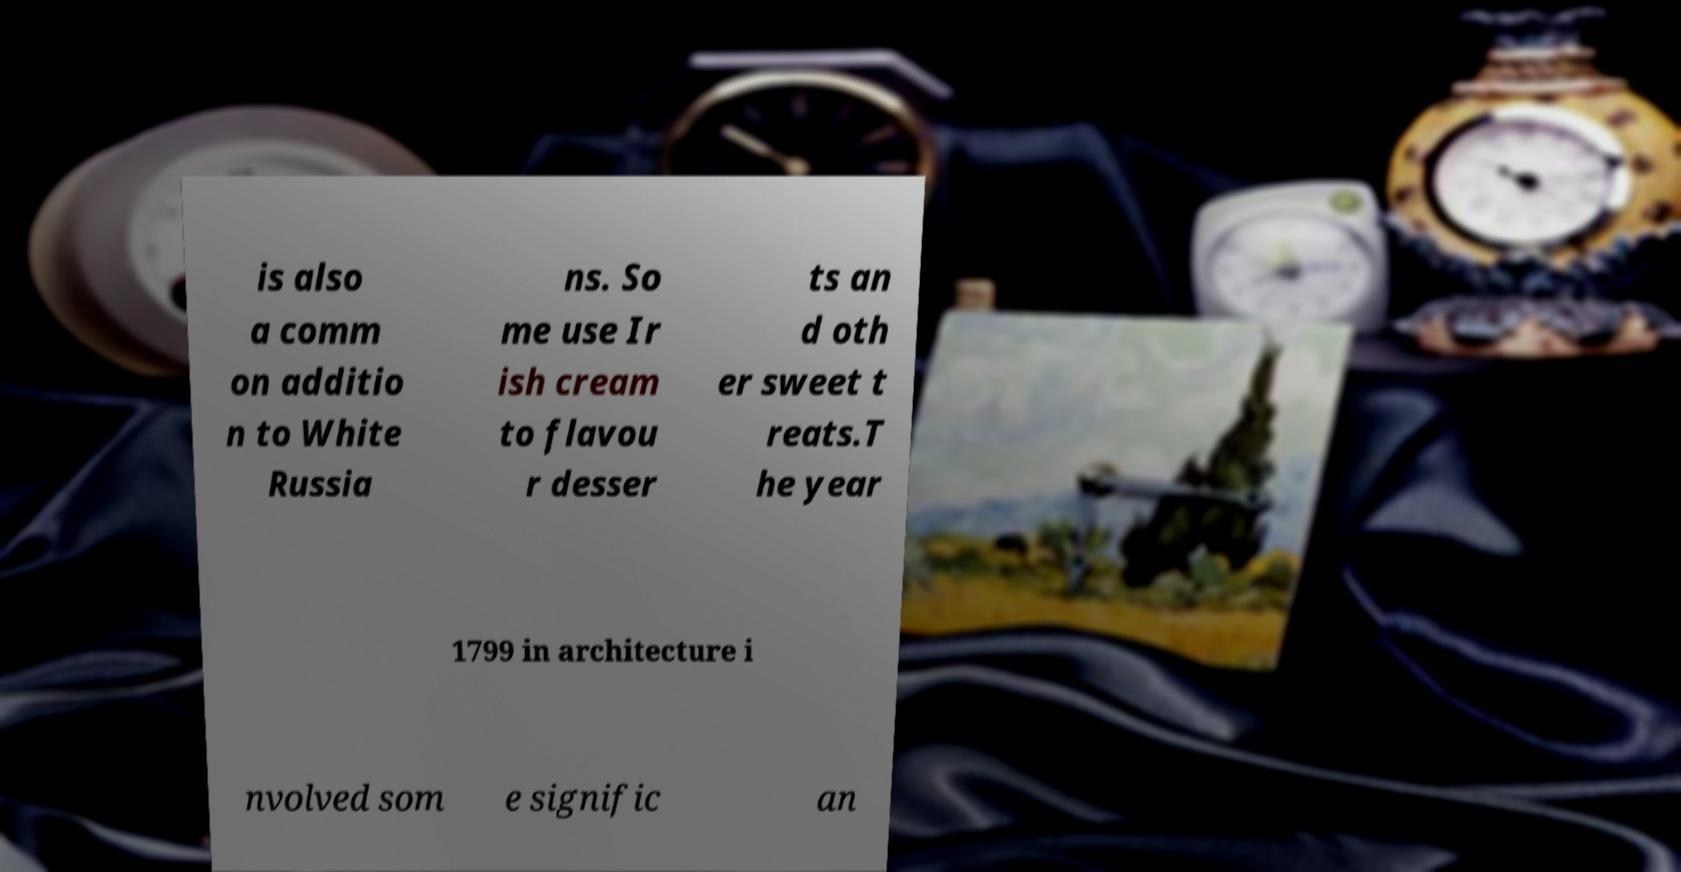Can you read and provide the text displayed in the image?This photo seems to have some interesting text. Can you extract and type it out for me? is also a comm on additio n to White Russia ns. So me use Ir ish cream to flavou r desser ts an d oth er sweet t reats.T he year 1799 in architecture i nvolved som e signific an 